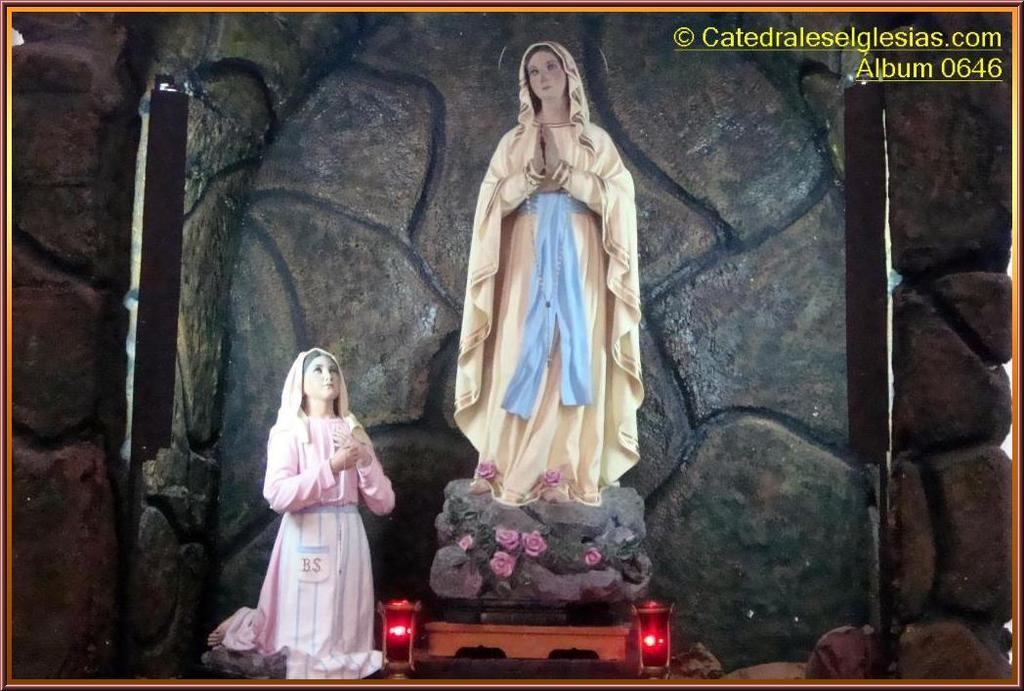What can be seen in the picture? There are idols in the picture. What is visible in the background of the picture? There is a stone wall in the background of the picture. How many clocks are present in the picture? There are no clocks visible in the picture; it features idols and a stone wall. What type of relation can be seen between the farmer and the idols in the picture? There is no farmer or any relation depicted in the picture; it only shows idols and a stone wall. 